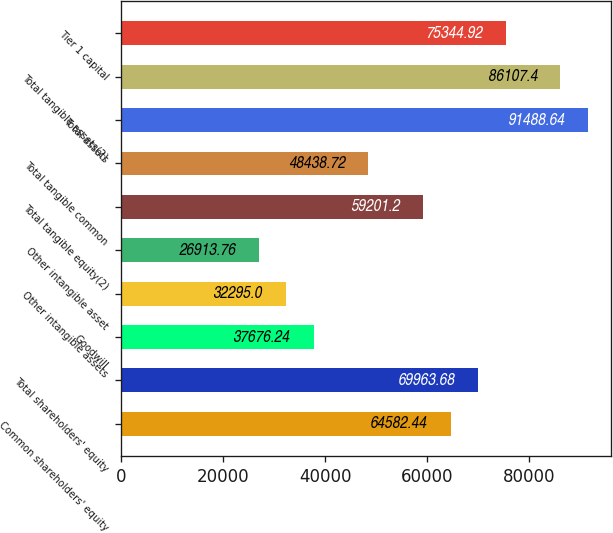Convert chart to OTSL. <chart><loc_0><loc_0><loc_500><loc_500><bar_chart><fcel>Common shareholders' equity<fcel>Total shareholders' equity<fcel>Goodwill<fcel>Other intangible assets<fcel>Other intangible asset<fcel>Total tangible equity(2)<fcel>Total tangible common<fcel>Total assets<fcel>Total tangible assets(2)<fcel>Tier 1 capital<nl><fcel>64582.4<fcel>69963.7<fcel>37676.2<fcel>32295<fcel>26913.8<fcel>59201.2<fcel>48438.7<fcel>91488.6<fcel>86107.4<fcel>75344.9<nl></chart> 